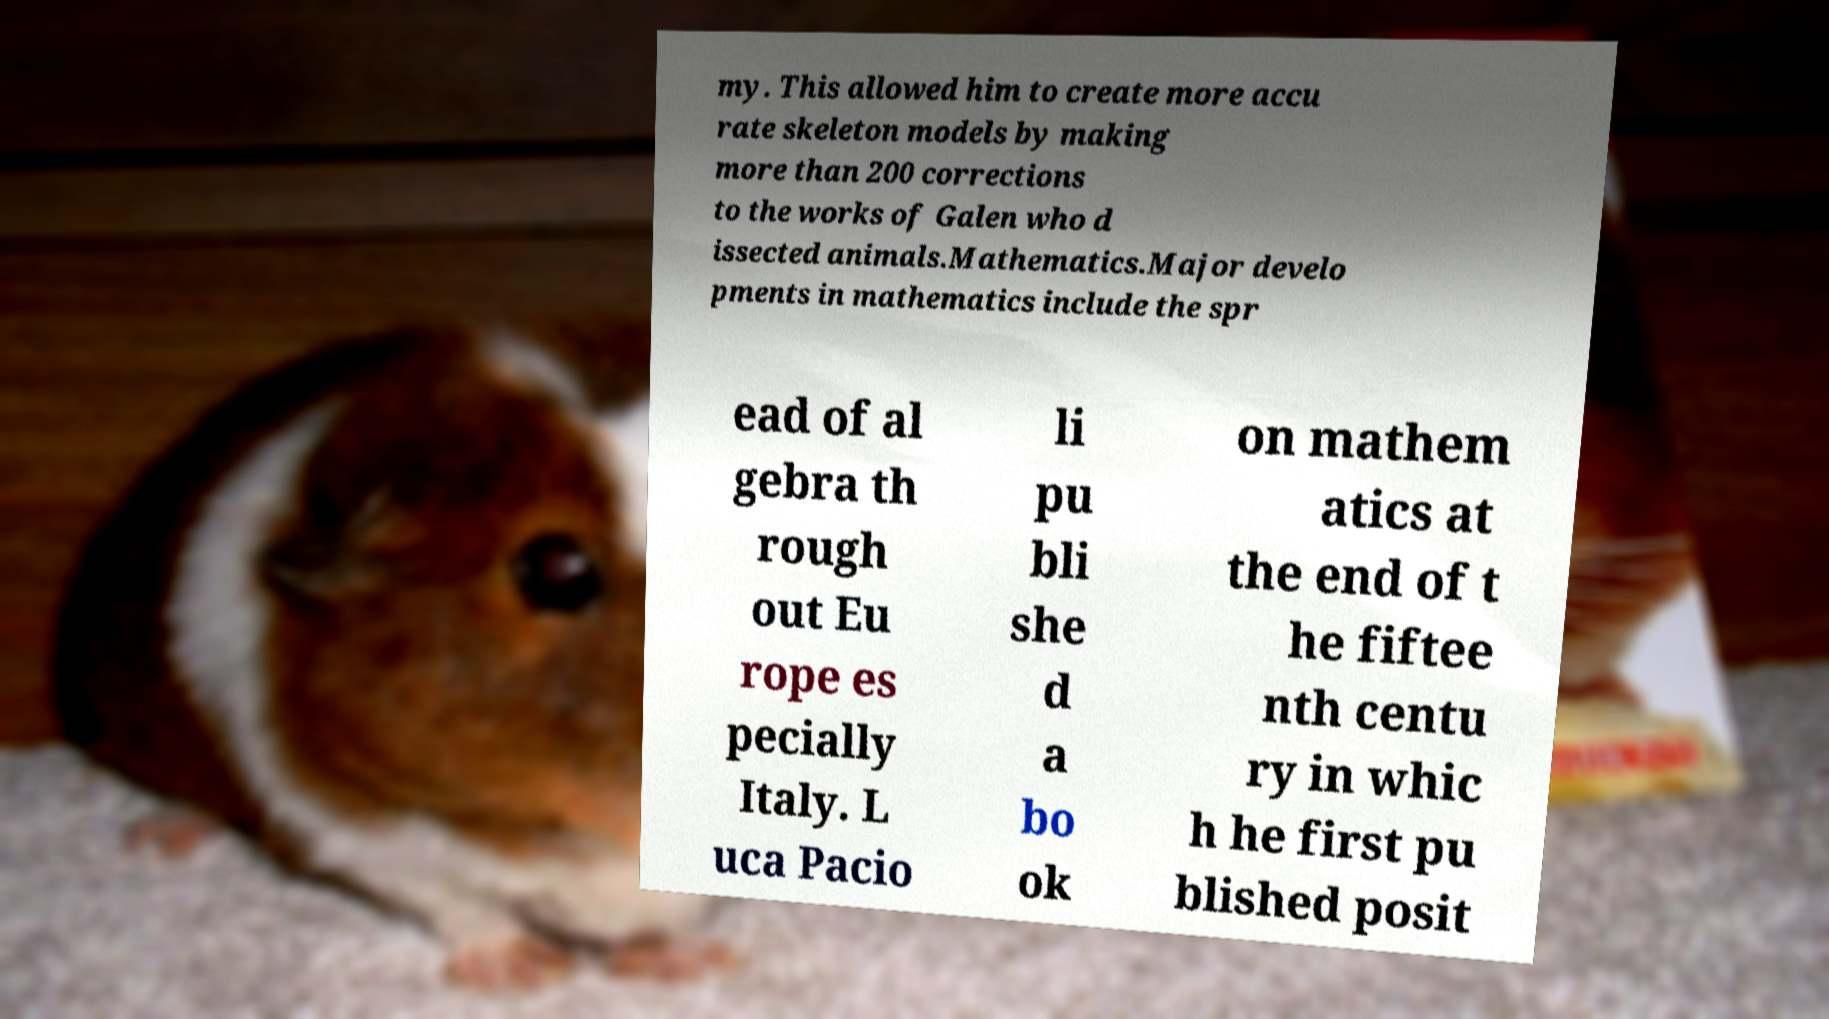What messages or text are displayed in this image? I need them in a readable, typed format. my. This allowed him to create more accu rate skeleton models by making more than 200 corrections to the works of Galen who d issected animals.Mathematics.Major develo pments in mathematics include the spr ead of al gebra th rough out Eu rope es pecially Italy. L uca Pacio li pu bli she d a bo ok on mathem atics at the end of t he fiftee nth centu ry in whic h he first pu blished posit 